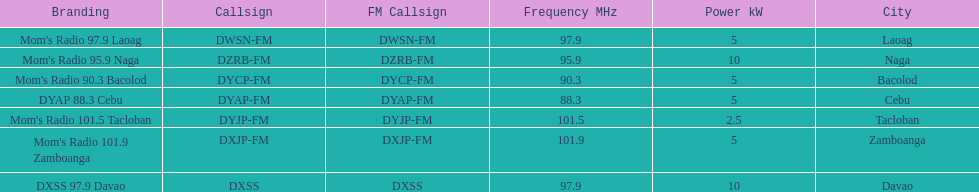What is the last location on this chart? Davao. 